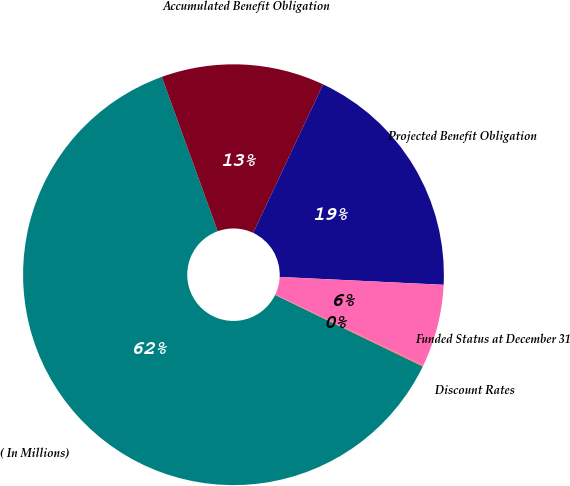<chart> <loc_0><loc_0><loc_500><loc_500><pie_chart><fcel>( In Millions)<fcel>Accumulated Benefit Obligation<fcel>Projected Benefit Obligation<fcel>Funded Status at December 31<fcel>Discount Rates<nl><fcel>62.29%<fcel>12.54%<fcel>18.76%<fcel>6.32%<fcel>0.1%<nl></chart> 